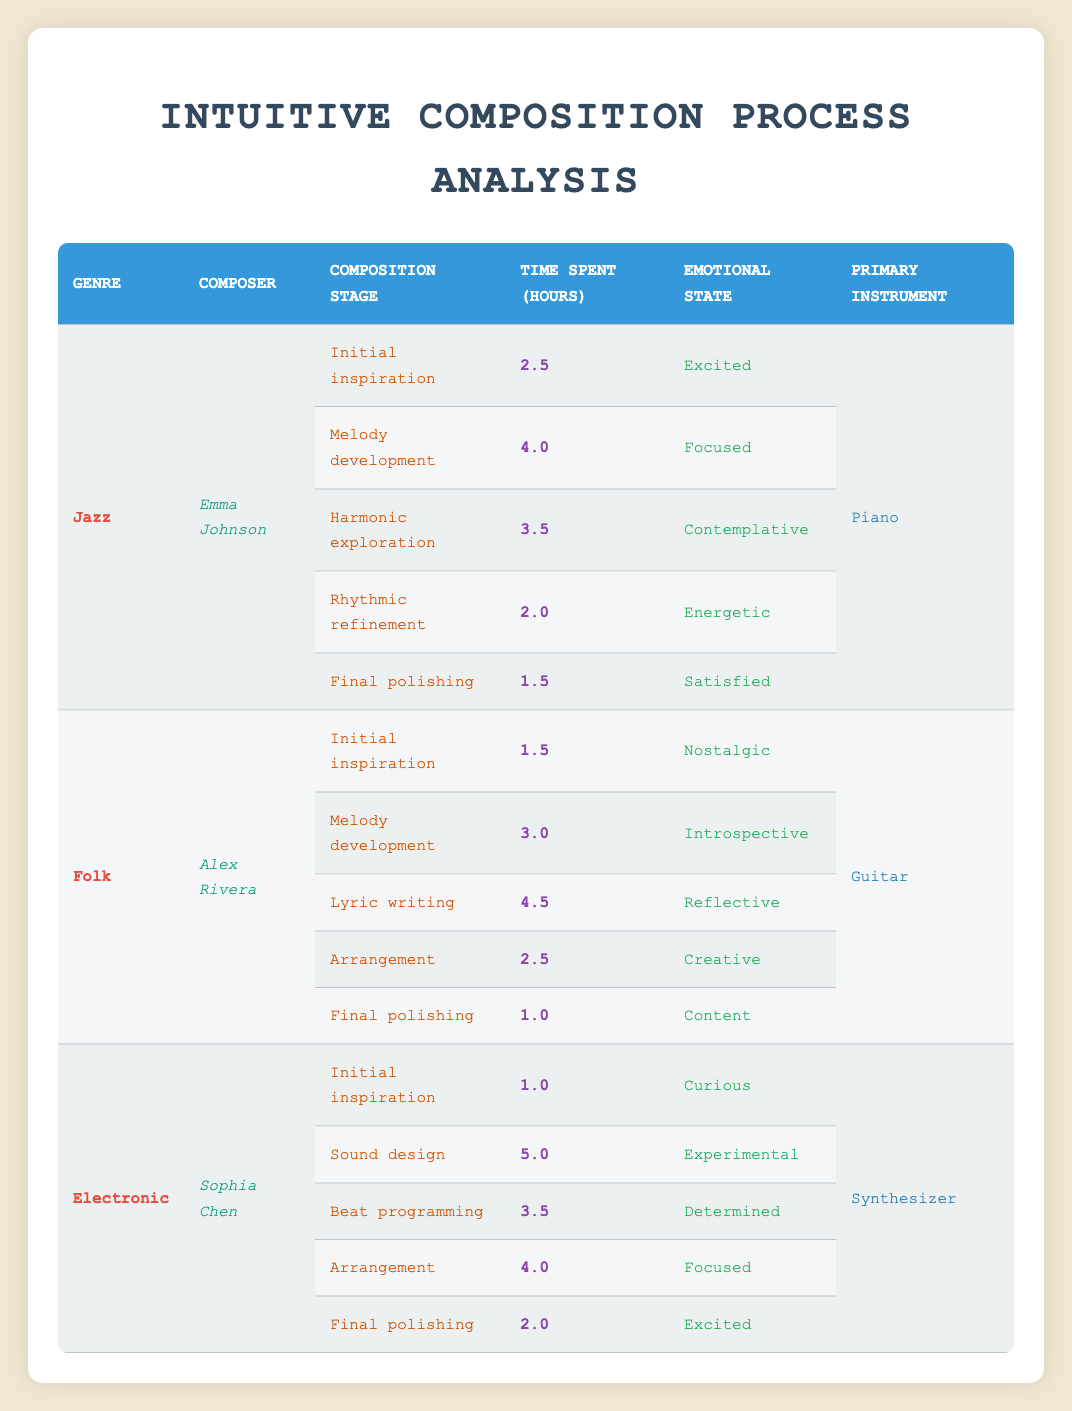What is the total time Emma Johnson spent on composition stages? Looking at the table, Emma Johnson spent 2.5 hours on initial inspiration, 4.0 hours on melody development, 3.5 hours on harmonic exploration, 2.0 hours on rhythmic refinement, and 1.5 hours on final polishing. Adding these together: 2.5 + 4.0 + 3.5 + 2.0 + 1.5 = 13.5 hours.
Answer: 13.5 hours Which genre had the longest single composition stage time? In the table, the maximum time spent on a single composition stage is 5.0 hours, found under the genre Electronic for the stage of sound design.
Answer: Electronic Did Alex Rivera spend more time on lyric writing or melody development? Alex Rivera spent 4.5 hours on lyric writing and 3.0 hours on melody development. Comparing the two, 4.5 is greater than 3.0, so he spent more time on lyric writing.
Answer: Yes What is the average time spent on the final polishing stage across all composers? Looking at the table, the times for final polishing are 1.5 hours (Emma), 1.0 hours (Alex), and 2.0 hours (Sophia). The average is calculated as follows: (1.5 + 1.0 + 2.0) / 3 = 1.5 hours.
Answer: 1.5 hours For the genre Folk, what emotional state was experienced during the lyric writing stage? Referring to the table, Alex Rivera experienced a reflective emotional state during the lyric writing stage, as specified in the corresponding row.
Answer: Reflective How many total hours did Sophia Chen spend on all composition stages combined? Sophia spent 1.0 hours on initial inspiration, 5.0 hours on sound design, 3.5 hours on beat programming, 4.0 hours on arrangement, and 2.0 hours on final polishing. Summing these: 1.0 + 5.0 + 3.5 + 4.0 + 2.0 = 15.5 hours.
Answer: 15.5 hours Was the time spent on rhythmic refinement by Emma Johnson greater than 2 hours? Emma Johnson spent 2.0 hours on rhythmic refinement as per the table. Since 2.0 is not greater than 2.0, the statement is false.
Answer: No Which composer took the least time on the final polishing stage, and how much time did they spend? In the table, Alex Rivera took the least time on final polishing, spending 1.0 hour, which is less than Emma's 1.5 and Sophia's 2.0 hours.
Answer: Alex Rivera, 1.0 hour What is the difference in time spent on sound design compared to melody development for Sophia Chen? Sophia spent 5.0 hours on sound design and 4.0 hours on arrangement. The difference in time would thus be: 5.0 - 4.0 = 1.0 hour.
Answer: 1.0 hour What is the emotional state of Emma Johnson while developing her melody? According to the table, Emma Johnson's emotional state was focused during the melody development stage, as indicated in her row.
Answer: Focused 